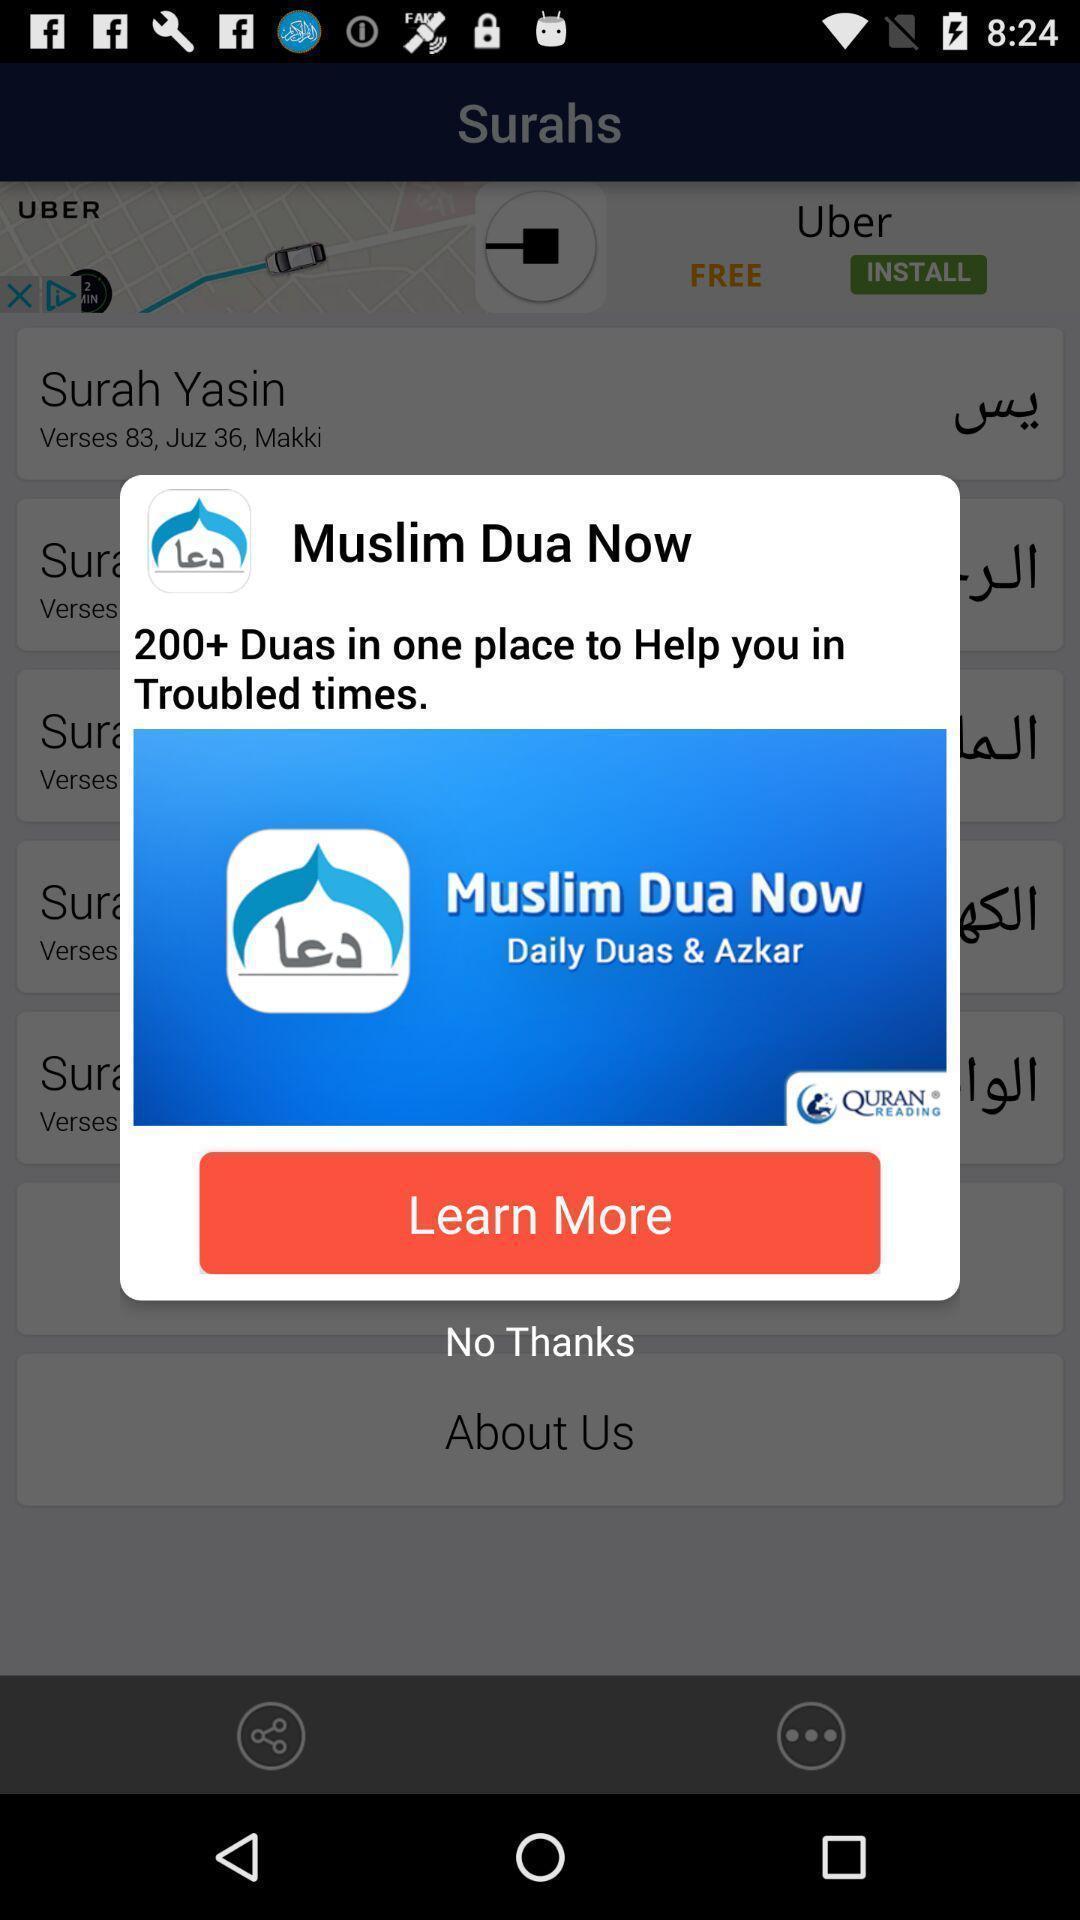Please provide a description for this image. Popup of the application to get the more information. 